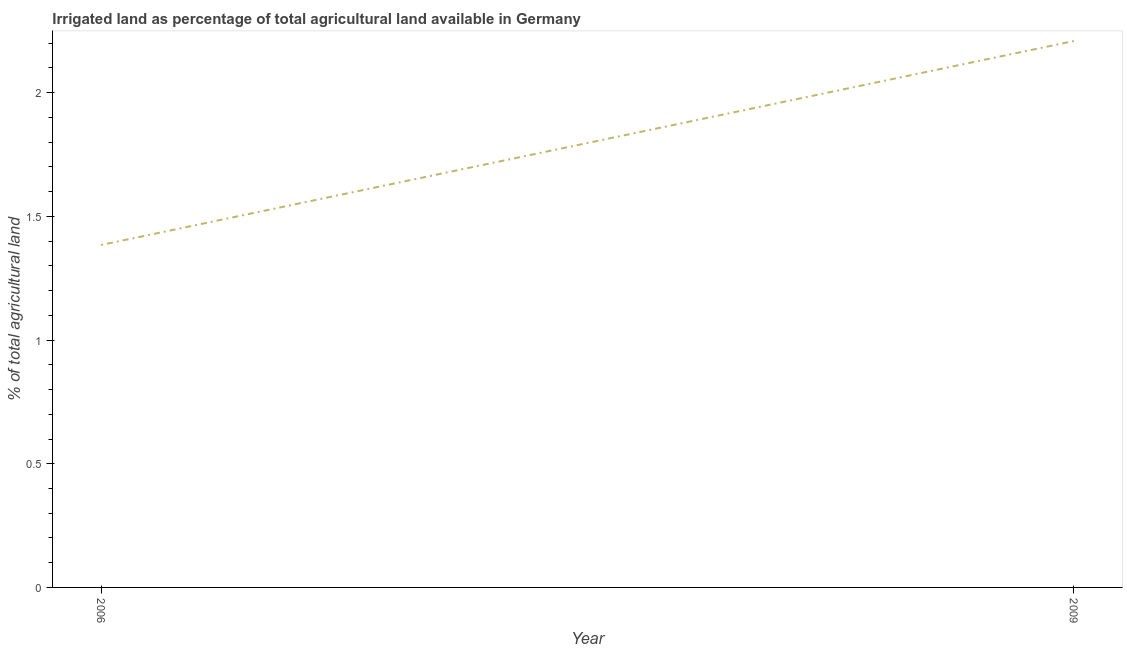What is the percentage of agricultural irrigated land in 2009?
Provide a succinct answer. 2.21. Across all years, what is the maximum percentage of agricultural irrigated land?
Your answer should be compact. 2.21. Across all years, what is the minimum percentage of agricultural irrigated land?
Make the answer very short. 1.38. In which year was the percentage of agricultural irrigated land maximum?
Offer a terse response. 2009. In which year was the percentage of agricultural irrigated land minimum?
Your answer should be very brief. 2006. What is the sum of the percentage of agricultural irrigated land?
Offer a terse response. 3.59. What is the difference between the percentage of agricultural irrigated land in 2006 and 2009?
Your answer should be compact. -0.82. What is the average percentage of agricultural irrigated land per year?
Your response must be concise. 1.8. What is the median percentage of agricultural irrigated land?
Keep it short and to the point. 1.8. In how many years, is the percentage of agricultural irrigated land greater than 1.6 %?
Offer a very short reply. 1. Do a majority of the years between 2009 and 2006 (inclusive) have percentage of agricultural irrigated land greater than 1.2 %?
Your response must be concise. No. What is the ratio of the percentage of agricultural irrigated land in 2006 to that in 2009?
Provide a succinct answer. 0.63. In how many years, is the percentage of agricultural irrigated land greater than the average percentage of agricultural irrigated land taken over all years?
Give a very brief answer. 1. How many years are there in the graph?
Give a very brief answer. 2. What is the difference between two consecutive major ticks on the Y-axis?
Your answer should be very brief. 0.5. Does the graph contain grids?
Keep it short and to the point. No. What is the title of the graph?
Offer a very short reply. Irrigated land as percentage of total agricultural land available in Germany. What is the label or title of the Y-axis?
Your answer should be compact. % of total agricultural land. What is the % of total agricultural land of 2006?
Your answer should be compact. 1.38. What is the % of total agricultural land in 2009?
Ensure brevity in your answer.  2.21. What is the difference between the % of total agricultural land in 2006 and 2009?
Offer a very short reply. -0.82. What is the ratio of the % of total agricultural land in 2006 to that in 2009?
Provide a succinct answer. 0.63. 